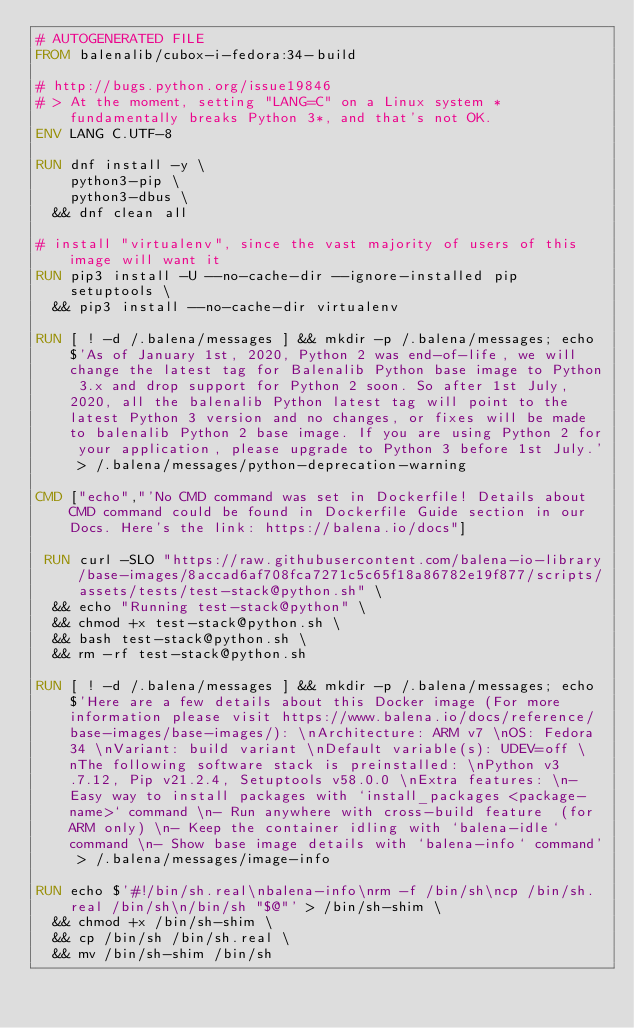Convert code to text. <code><loc_0><loc_0><loc_500><loc_500><_Dockerfile_># AUTOGENERATED FILE
FROM balenalib/cubox-i-fedora:34-build

# http://bugs.python.org/issue19846
# > At the moment, setting "LANG=C" on a Linux system *fundamentally breaks Python 3*, and that's not OK.
ENV LANG C.UTF-8

RUN dnf install -y \
		python3-pip \
		python3-dbus \
	&& dnf clean all

# install "virtualenv", since the vast majority of users of this image will want it
RUN pip3 install -U --no-cache-dir --ignore-installed pip setuptools \
	&& pip3 install --no-cache-dir virtualenv

RUN [ ! -d /.balena/messages ] && mkdir -p /.balena/messages; echo $'As of January 1st, 2020, Python 2 was end-of-life, we will change the latest tag for Balenalib Python base image to Python 3.x and drop support for Python 2 soon. So after 1st July, 2020, all the balenalib Python latest tag will point to the latest Python 3 version and no changes, or fixes will be made to balenalib Python 2 base image. If you are using Python 2 for your application, please upgrade to Python 3 before 1st July.' > /.balena/messages/python-deprecation-warning

CMD ["echo","'No CMD command was set in Dockerfile! Details about CMD command could be found in Dockerfile Guide section in our Docs. Here's the link: https://balena.io/docs"]

 RUN curl -SLO "https://raw.githubusercontent.com/balena-io-library/base-images/8accad6af708fca7271c5c65f18a86782e19f877/scripts/assets/tests/test-stack@python.sh" \
  && echo "Running test-stack@python" \
  && chmod +x test-stack@python.sh \
  && bash test-stack@python.sh \
  && rm -rf test-stack@python.sh 

RUN [ ! -d /.balena/messages ] && mkdir -p /.balena/messages; echo $'Here are a few details about this Docker image (For more information please visit https://www.balena.io/docs/reference/base-images/base-images/): \nArchitecture: ARM v7 \nOS: Fedora 34 \nVariant: build variant \nDefault variable(s): UDEV=off \nThe following software stack is preinstalled: \nPython v3.7.12, Pip v21.2.4, Setuptools v58.0.0 \nExtra features: \n- Easy way to install packages with `install_packages <package-name>` command \n- Run anywhere with cross-build feature  (for ARM only) \n- Keep the container idling with `balena-idle` command \n- Show base image details with `balena-info` command' > /.balena/messages/image-info

RUN echo $'#!/bin/sh.real\nbalena-info\nrm -f /bin/sh\ncp /bin/sh.real /bin/sh\n/bin/sh "$@"' > /bin/sh-shim \
	&& chmod +x /bin/sh-shim \
	&& cp /bin/sh /bin/sh.real \
	&& mv /bin/sh-shim /bin/sh</code> 